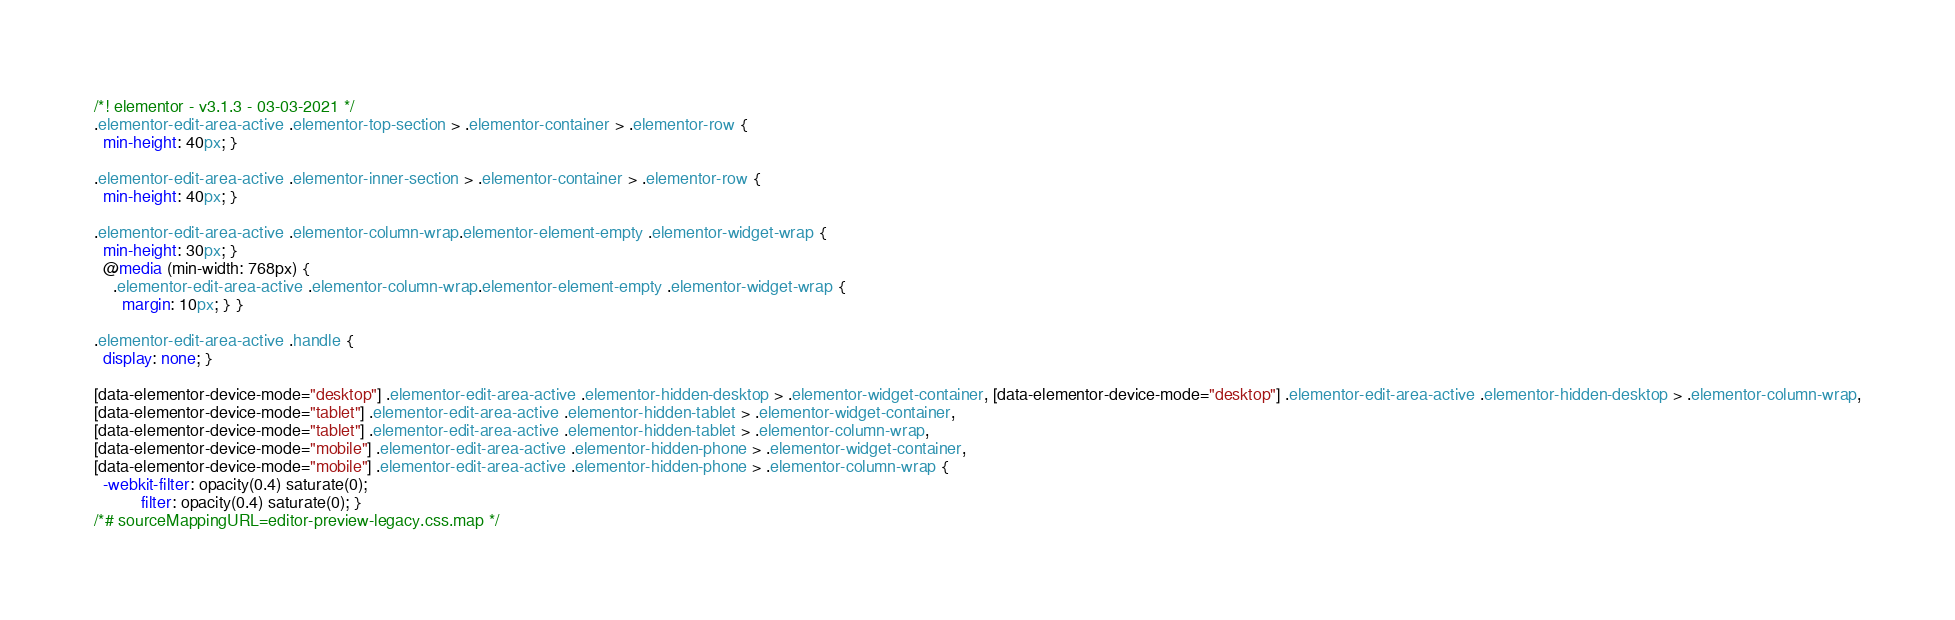Convert code to text. <code><loc_0><loc_0><loc_500><loc_500><_CSS_>/*! elementor - v3.1.3 - 03-03-2021 */
.elementor-edit-area-active .elementor-top-section > .elementor-container > .elementor-row {
  min-height: 40px; }

.elementor-edit-area-active .elementor-inner-section > .elementor-container > .elementor-row {
  min-height: 40px; }

.elementor-edit-area-active .elementor-column-wrap.elementor-element-empty .elementor-widget-wrap {
  min-height: 30px; }
  @media (min-width: 768px) {
    .elementor-edit-area-active .elementor-column-wrap.elementor-element-empty .elementor-widget-wrap {
      margin: 10px; } }

.elementor-edit-area-active .handle {
  display: none; }

[data-elementor-device-mode="desktop"] .elementor-edit-area-active .elementor-hidden-desktop > .elementor-widget-container, [data-elementor-device-mode="desktop"] .elementor-edit-area-active .elementor-hidden-desktop > .elementor-column-wrap,
[data-elementor-device-mode="tablet"] .elementor-edit-area-active .elementor-hidden-tablet > .elementor-widget-container,
[data-elementor-device-mode="tablet"] .elementor-edit-area-active .elementor-hidden-tablet > .elementor-column-wrap,
[data-elementor-device-mode="mobile"] .elementor-edit-area-active .elementor-hidden-phone > .elementor-widget-container,
[data-elementor-device-mode="mobile"] .elementor-edit-area-active .elementor-hidden-phone > .elementor-column-wrap {
  -webkit-filter: opacity(0.4) saturate(0);
          filter: opacity(0.4) saturate(0); }
/*# sourceMappingURL=editor-preview-legacy.css.map */</code> 